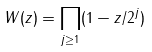Convert formula to latex. <formula><loc_0><loc_0><loc_500><loc_500>W ( z ) = \prod _ { j \geq 1 } ( 1 - z / 2 ^ { j } )</formula> 